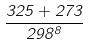Convert formula to latex. <formula><loc_0><loc_0><loc_500><loc_500>\frac { 3 2 5 + 2 7 3 } { 2 9 8 ^ { 8 } }</formula> 